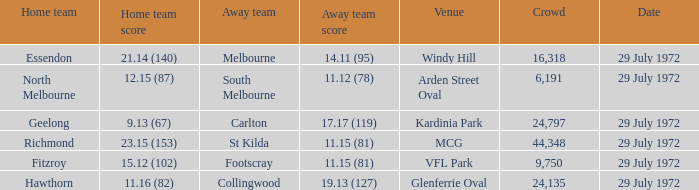What was the largest crowd size at arden street oval? 6191.0. 